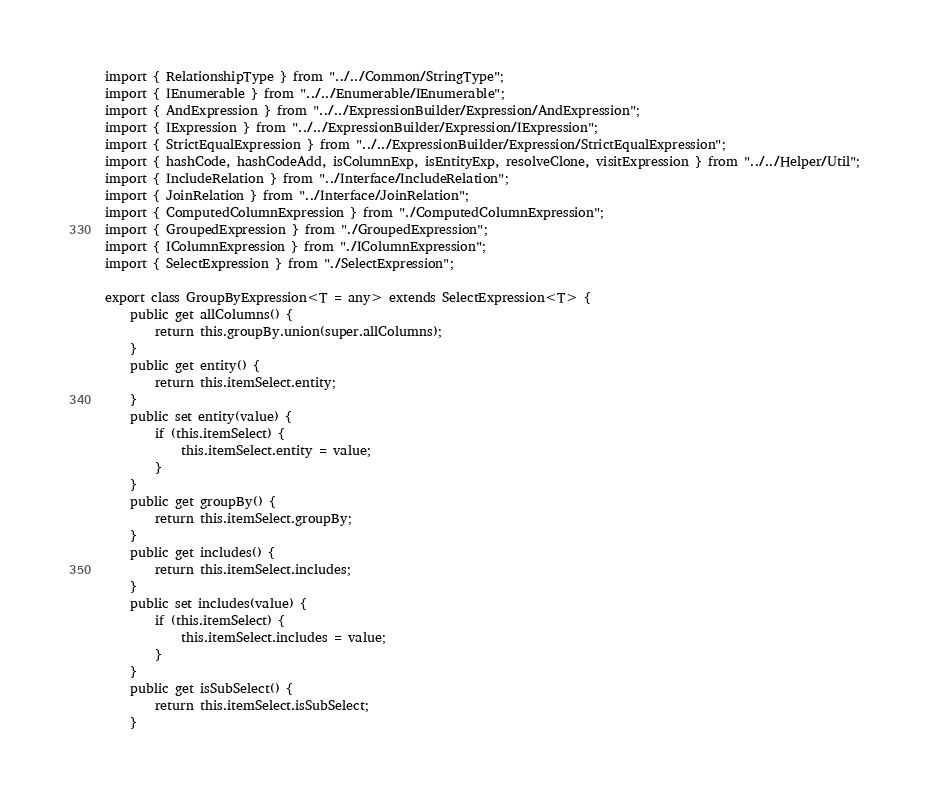Convert code to text. <code><loc_0><loc_0><loc_500><loc_500><_TypeScript_>import { RelationshipType } from "../../Common/StringType";
import { IEnumerable } from "../../Enumerable/IEnumerable";
import { AndExpression } from "../../ExpressionBuilder/Expression/AndExpression";
import { IExpression } from "../../ExpressionBuilder/Expression/IExpression";
import { StrictEqualExpression } from "../../ExpressionBuilder/Expression/StrictEqualExpression";
import { hashCode, hashCodeAdd, isColumnExp, isEntityExp, resolveClone, visitExpression } from "../../Helper/Util";
import { IncludeRelation } from "../Interface/IncludeRelation";
import { JoinRelation } from "../Interface/JoinRelation";
import { ComputedColumnExpression } from "./ComputedColumnExpression";
import { GroupedExpression } from "./GroupedExpression";
import { IColumnExpression } from "./IColumnExpression";
import { SelectExpression } from "./SelectExpression";

export class GroupByExpression<T = any> extends SelectExpression<T> {
    public get allColumns() {
        return this.groupBy.union(super.allColumns);
    }
    public get entity() {
        return this.itemSelect.entity;
    }
    public set entity(value) {
        if (this.itemSelect) {
            this.itemSelect.entity = value;
        }
    }
    public get groupBy() {
        return this.itemSelect.groupBy;
    }
    public get includes() {
        return this.itemSelect.includes;
    }
    public set includes(value) {
        if (this.itemSelect) {
            this.itemSelect.includes = value;
        }
    }
    public get isSubSelect() {
        return this.itemSelect.isSubSelect;
    }</code> 